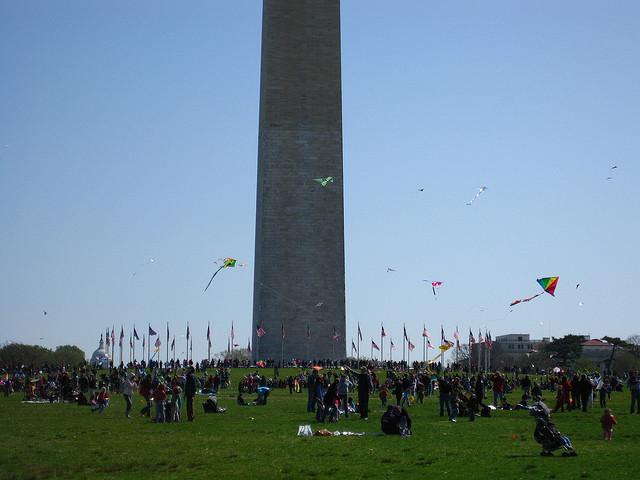Are theses kites higher than the monument?
Write a very short answer. No. How tall is the monument?
Give a very brief answer. 500 feet. Are there clouds visible?
Short answer required. No. Is it cloudy outside?
Give a very brief answer. No. What are the people doing at the park?
Write a very short answer. Flying kites. What is surrounding the monument?
Give a very brief answer. Flags. 